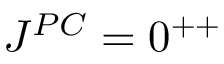Convert formula to latex. <formula><loc_0><loc_0><loc_500><loc_500>J ^ { P C } = 0 ^ { + + }</formula> 